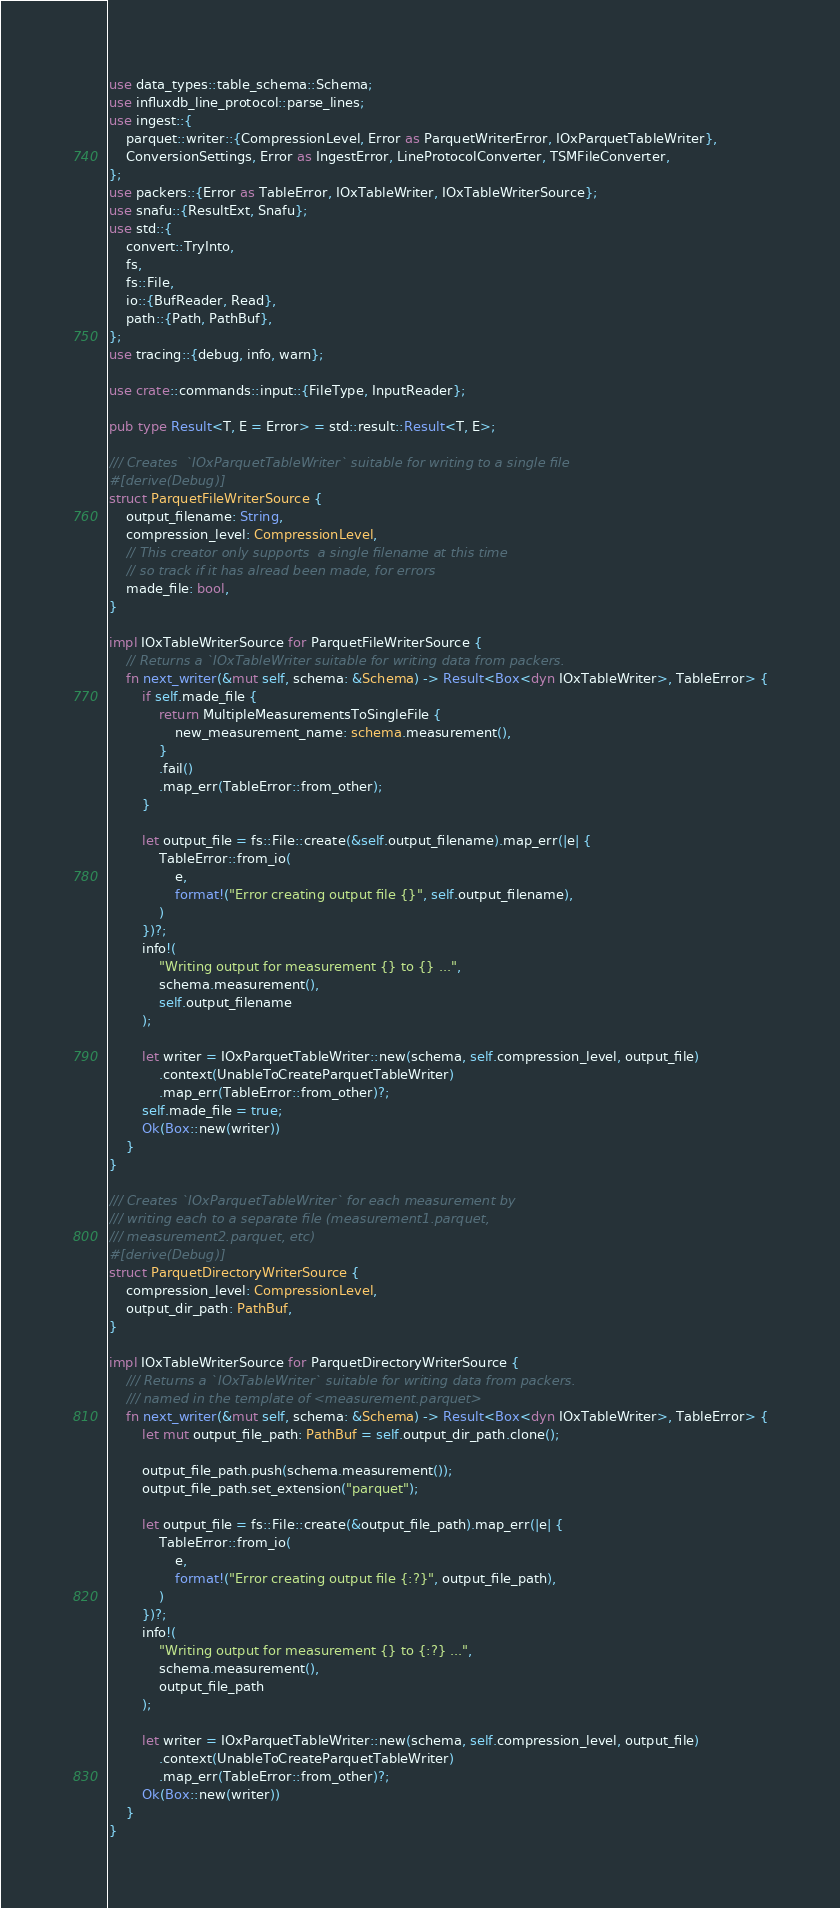<code> <loc_0><loc_0><loc_500><loc_500><_Rust_>use data_types::table_schema::Schema;
use influxdb_line_protocol::parse_lines;
use ingest::{
    parquet::writer::{CompressionLevel, Error as ParquetWriterError, IOxParquetTableWriter},
    ConversionSettings, Error as IngestError, LineProtocolConverter, TSMFileConverter,
};
use packers::{Error as TableError, IOxTableWriter, IOxTableWriterSource};
use snafu::{ResultExt, Snafu};
use std::{
    convert::TryInto,
    fs,
    fs::File,
    io::{BufReader, Read},
    path::{Path, PathBuf},
};
use tracing::{debug, info, warn};

use crate::commands::input::{FileType, InputReader};

pub type Result<T, E = Error> = std::result::Result<T, E>;

/// Creates  `IOxParquetTableWriter` suitable for writing to a single file
#[derive(Debug)]
struct ParquetFileWriterSource {
    output_filename: String,
    compression_level: CompressionLevel,
    // This creator only supports  a single filename at this time
    // so track if it has alread been made, for errors
    made_file: bool,
}

impl IOxTableWriterSource for ParquetFileWriterSource {
    // Returns a `IOxTableWriter suitable for writing data from packers.
    fn next_writer(&mut self, schema: &Schema) -> Result<Box<dyn IOxTableWriter>, TableError> {
        if self.made_file {
            return MultipleMeasurementsToSingleFile {
                new_measurement_name: schema.measurement(),
            }
            .fail()
            .map_err(TableError::from_other);
        }

        let output_file = fs::File::create(&self.output_filename).map_err(|e| {
            TableError::from_io(
                e,
                format!("Error creating output file {}", self.output_filename),
            )
        })?;
        info!(
            "Writing output for measurement {} to {} ...",
            schema.measurement(),
            self.output_filename
        );

        let writer = IOxParquetTableWriter::new(schema, self.compression_level, output_file)
            .context(UnableToCreateParquetTableWriter)
            .map_err(TableError::from_other)?;
        self.made_file = true;
        Ok(Box::new(writer))
    }
}

/// Creates `IOxParquetTableWriter` for each measurement by
/// writing each to a separate file (measurement1.parquet,
/// measurement2.parquet, etc)
#[derive(Debug)]
struct ParquetDirectoryWriterSource {
    compression_level: CompressionLevel,
    output_dir_path: PathBuf,
}

impl IOxTableWriterSource for ParquetDirectoryWriterSource {
    /// Returns a `IOxTableWriter` suitable for writing data from packers.
    /// named in the template of <measurement.parquet>
    fn next_writer(&mut self, schema: &Schema) -> Result<Box<dyn IOxTableWriter>, TableError> {
        let mut output_file_path: PathBuf = self.output_dir_path.clone();

        output_file_path.push(schema.measurement());
        output_file_path.set_extension("parquet");

        let output_file = fs::File::create(&output_file_path).map_err(|e| {
            TableError::from_io(
                e,
                format!("Error creating output file {:?}", output_file_path),
            )
        })?;
        info!(
            "Writing output for measurement {} to {:?} ...",
            schema.measurement(),
            output_file_path
        );

        let writer = IOxParquetTableWriter::new(schema, self.compression_level, output_file)
            .context(UnableToCreateParquetTableWriter)
            .map_err(TableError::from_other)?;
        Ok(Box::new(writer))
    }
}
</code> 